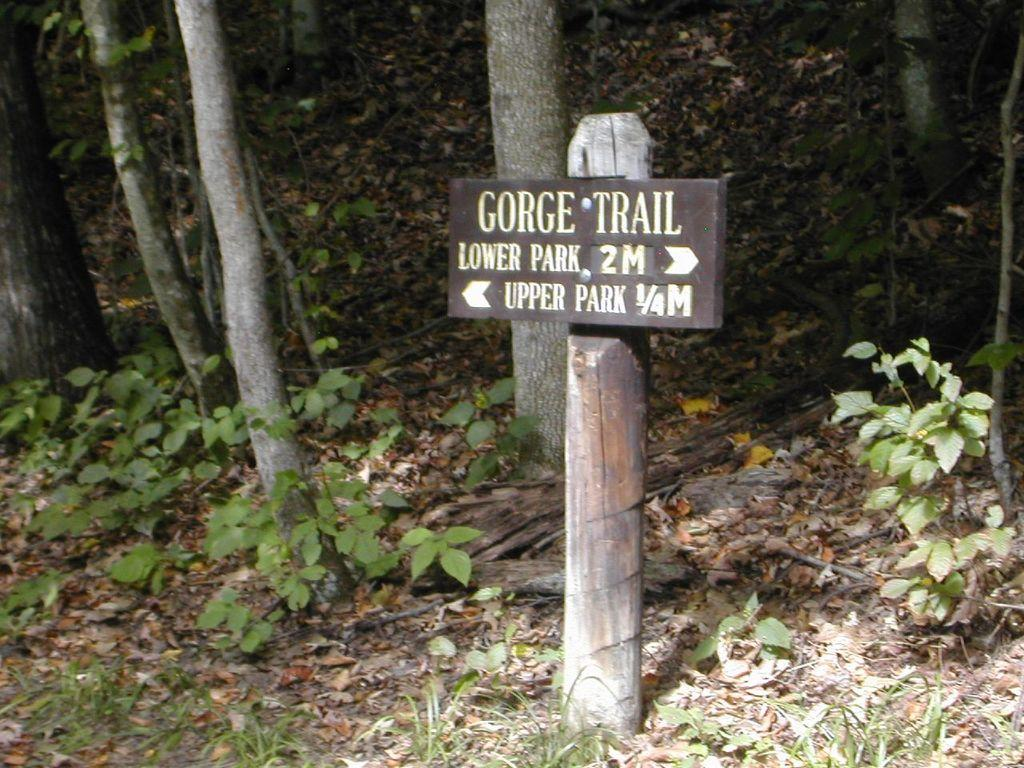What is the main object in the center of the image? There is a sign board in the center of the image. What can be seen in the background of the image? There are tree trunks in the background of the image. What type of vegetation is at the bottom of the image? There is grass at the bottom of the image. What type of stone is being used to support the sign board in the image? There is no stone visible in the image; the sign board is not supported by any stone. 